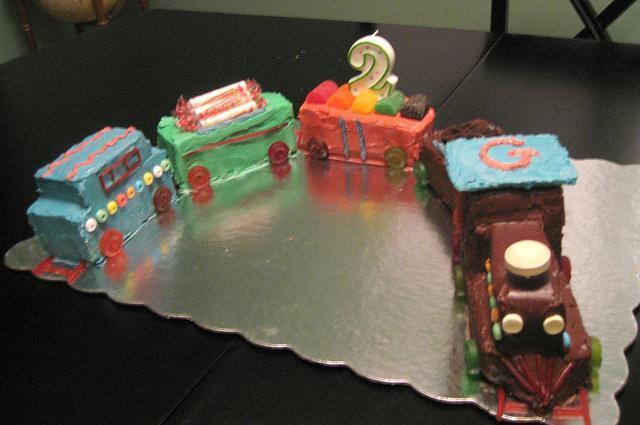How many cakes can be seen?
Give a very brief answer. 4. 